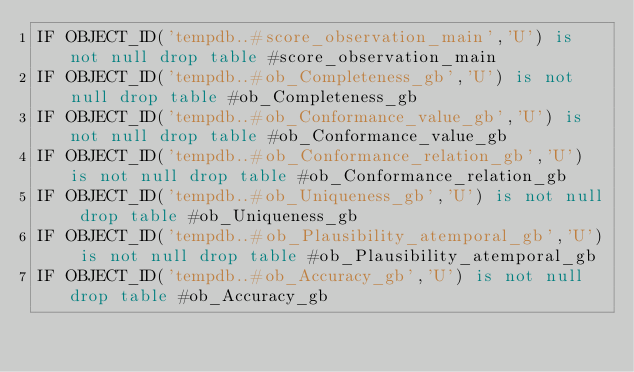Convert code to text. <code><loc_0><loc_0><loc_500><loc_500><_SQL_>IF OBJECT_ID('tempdb..#score_observation_main','U') is not null drop table #score_observation_main 
IF OBJECT_ID('tempdb..#ob_Completeness_gb','U') is not null drop table #ob_Completeness_gb 
IF OBJECT_ID('tempdb..#ob_Conformance_value_gb','U') is not null drop table #ob_Conformance_value_gb 
IF OBJECT_ID('tempdb..#ob_Conformance_relation_gb','U') is not null drop table #ob_Conformance_relation_gb 
IF OBJECT_ID('tempdb..#ob_Uniqueness_gb','U') is not null drop table #ob_Uniqueness_gb 
IF OBJECT_ID('tempdb..#ob_Plausibility_atemporal_gb','U') is not null drop table #ob_Plausibility_atemporal_gb 
IF OBJECT_ID('tempdb..#ob_Accuracy_gb','U') is not null drop table #ob_Accuracy_gb </code> 